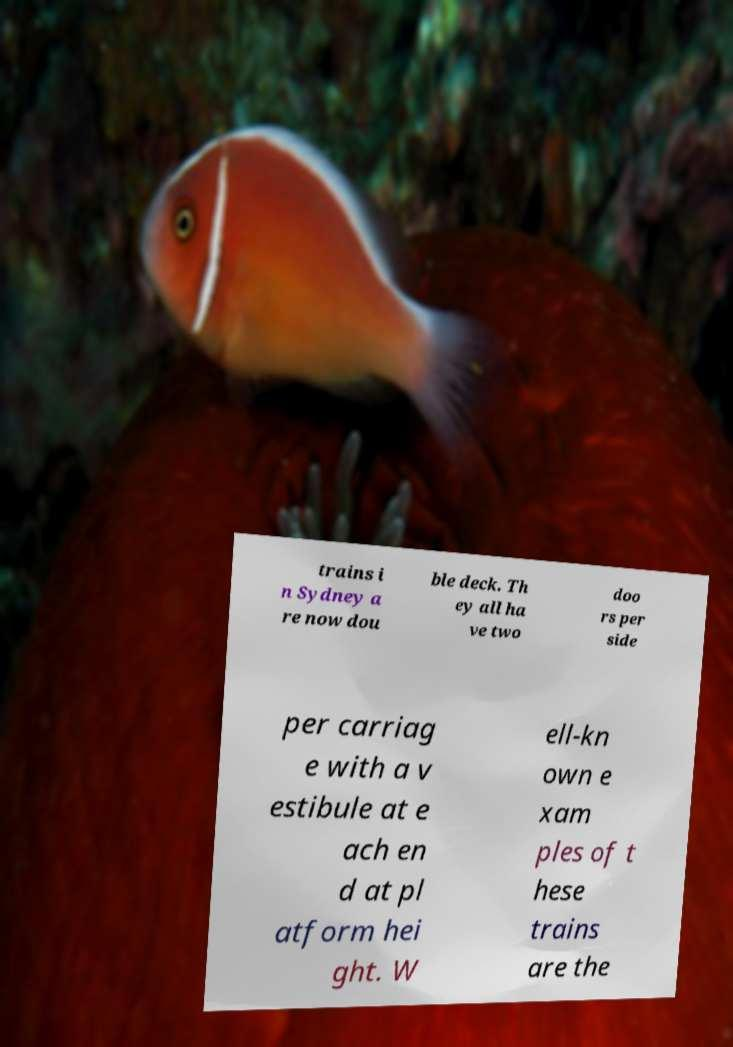Please identify and transcribe the text found in this image. trains i n Sydney a re now dou ble deck. Th ey all ha ve two doo rs per side per carriag e with a v estibule at e ach en d at pl atform hei ght. W ell-kn own e xam ples of t hese trains are the 